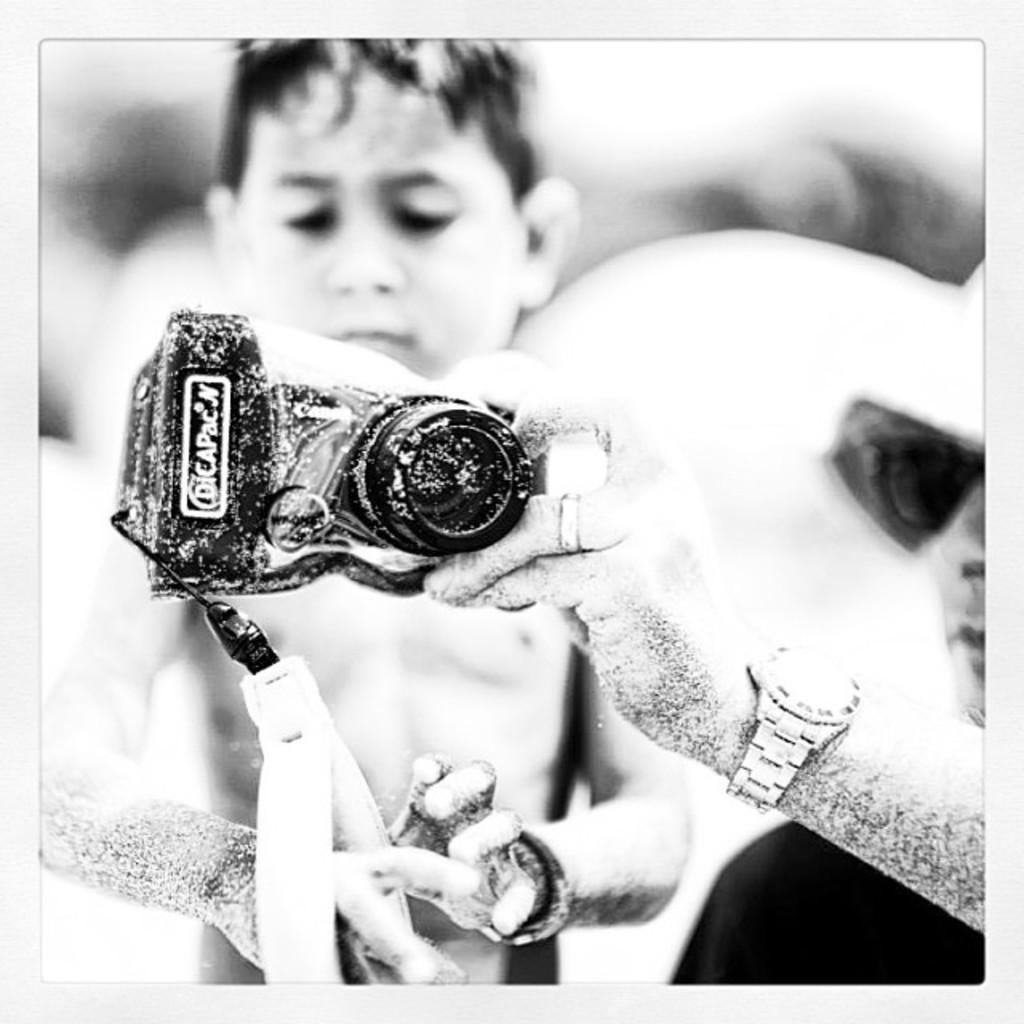How many people are in the image? There are two people in the image. Can you describe the appearance of the man on the right side? The man on the right side is wearing spectacles. What is the man on the right side holding? The man on the right side is holding a camera. How would you describe the background of the image? The background of the image is blurry. What type of pump is being used by the man on the left side of the image? There is no pump present in the image; it only features two people, one of whom is holding a camera. 